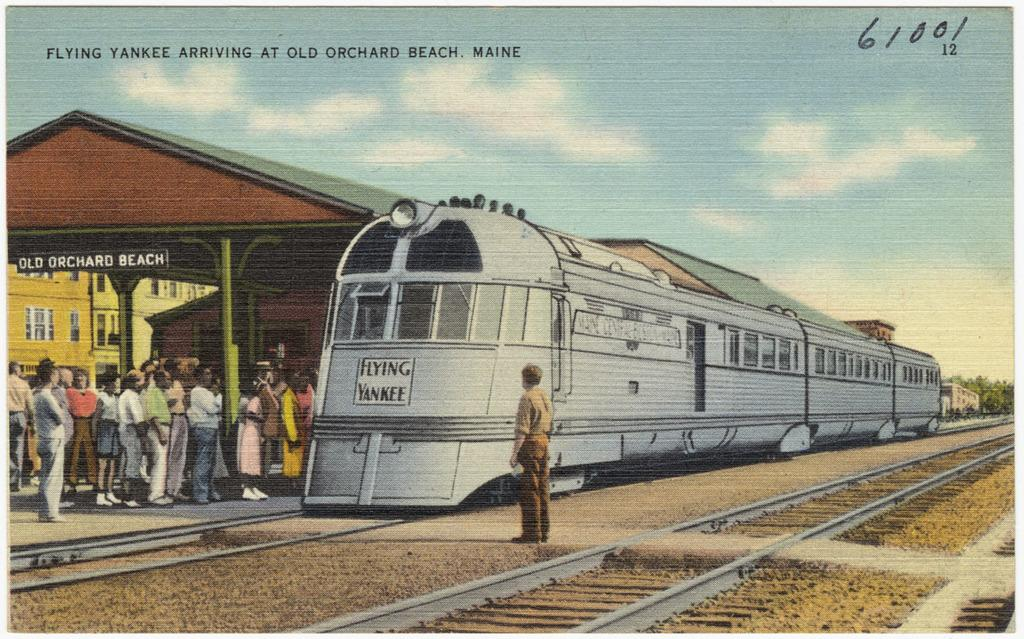<image>
Describe the image concisely. A postcard depicts a train and the number 61001 in the corner. 